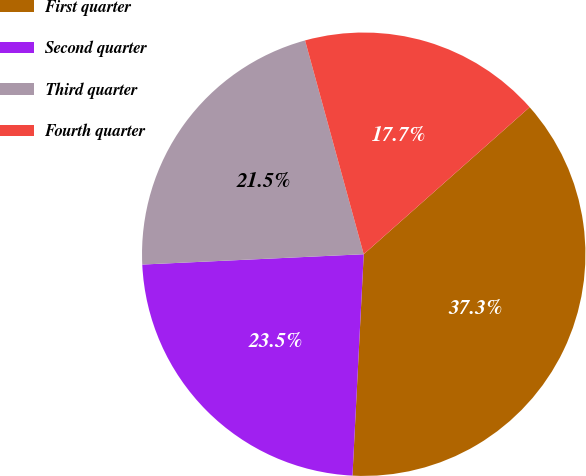Convert chart to OTSL. <chart><loc_0><loc_0><loc_500><loc_500><pie_chart><fcel>First quarter<fcel>Second quarter<fcel>Third quarter<fcel>Fourth quarter<nl><fcel>37.35%<fcel>23.45%<fcel>21.48%<fcel>17.72%<nl></chart> 